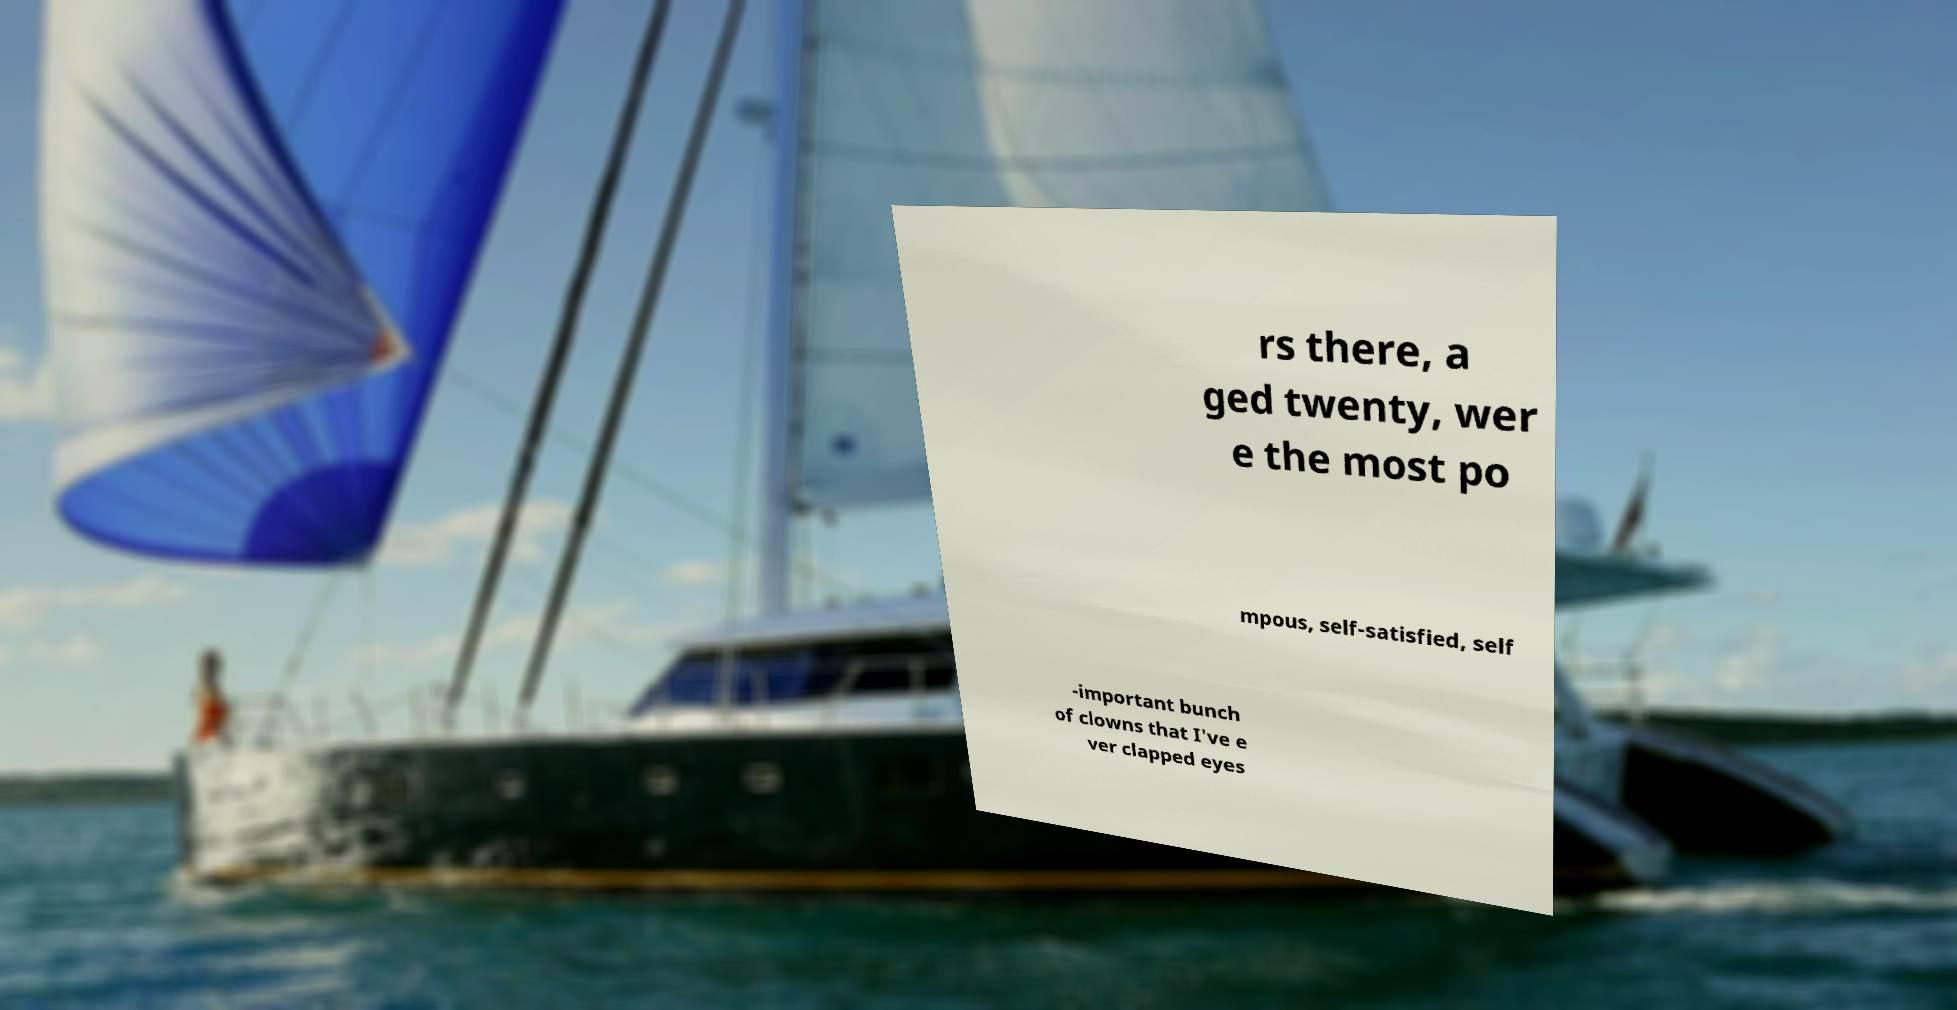What messages or text are displayed in this image? I need them in a readable, typed format. rs there, a ged twenty, wer e the most po mpous, self-satisfied, self -important bunch of clowns that I've e ver clapped eyes 